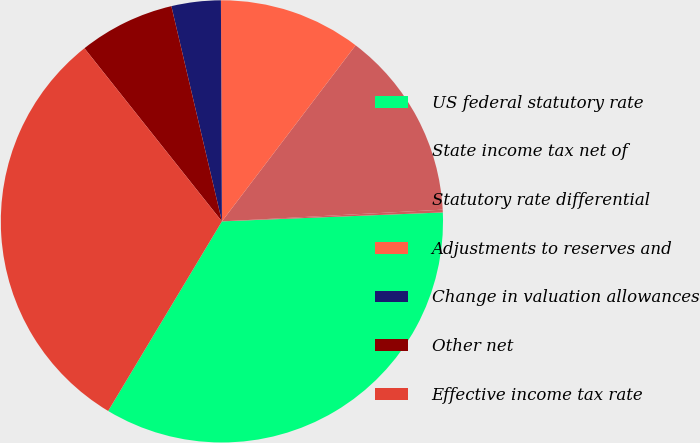Convert chart. <chart><loc_0><loc_0><loc_500><loc_500><pie_chart><fcel>US federal statutory rate<fcel>State income tax net of<fcel>Statutory rate differential<fcel>Adjustments to reserves and<fcel>Change in valuation allowances<fcel>Other net<fcel>Effective income tax rate<nl><fcel>34.25%<fcel>0.2%<fcel>13.82%<fcel>10.41%<fcel>3.6%<fcel>7.01%<fcel>30.72%<nl></chart> 